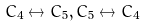<formula> <loc_0><loc_0><loc_500><loc_500>C _ { 4 } \leftrightarrow C _ { 5 } , C _ { 5 } \leftrightarrow C _ { 4 }</formula> 